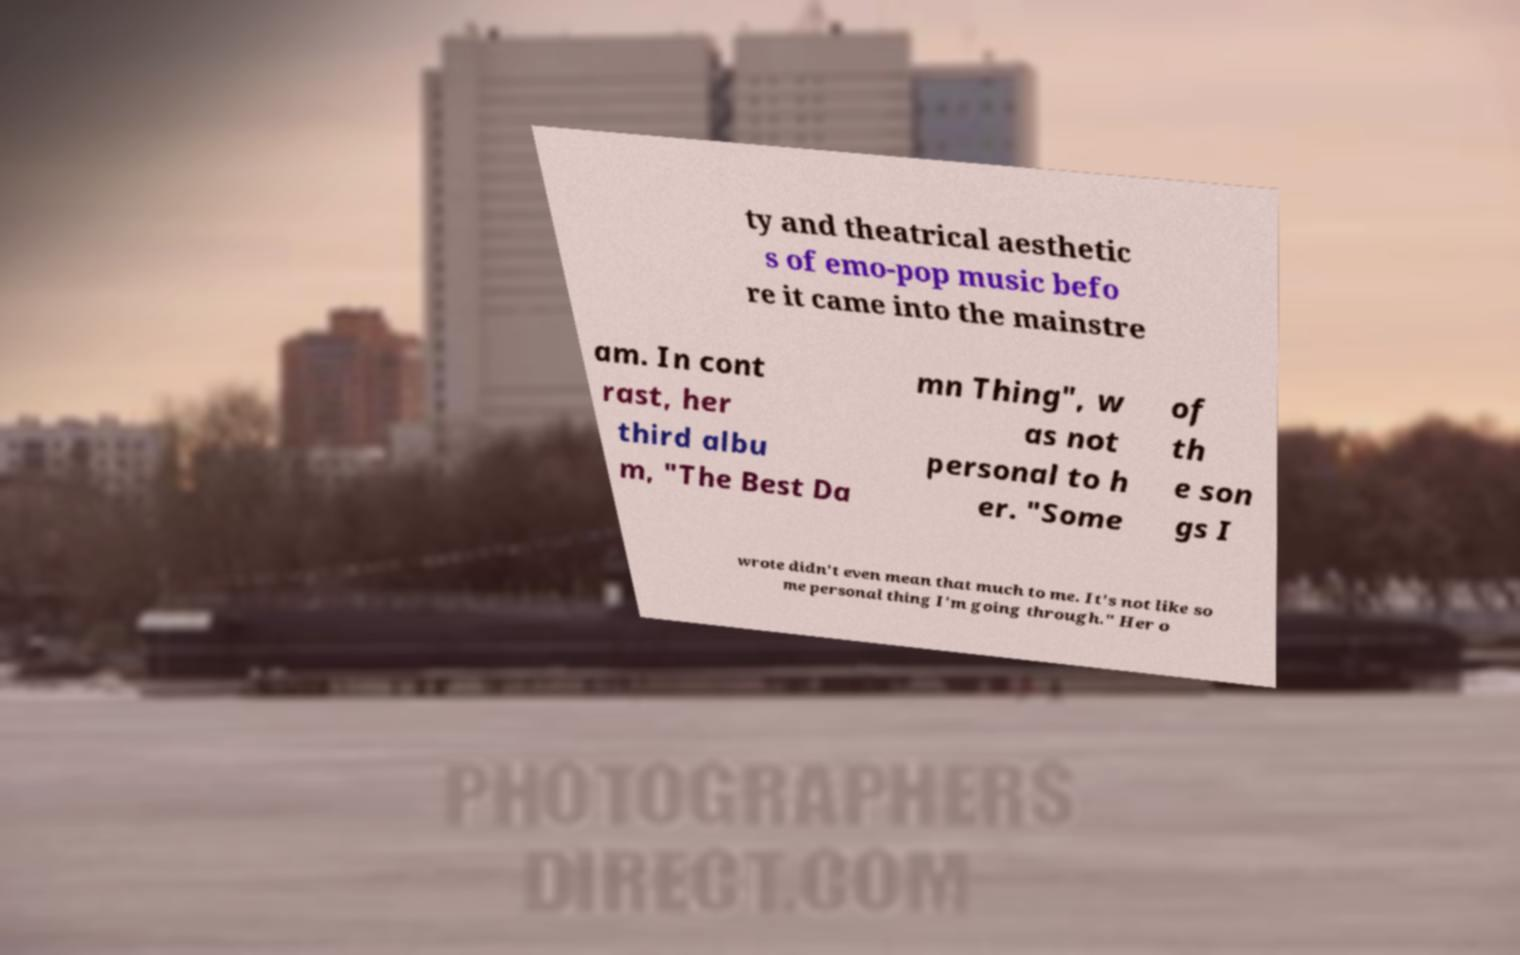There's text embedded in this image that I need extracted. Can you transcribe it verbatim? ty and theatrical aesthetic s of emo-pop music befo re it came into the mainstre am. In cont rast, her third albu m, "The Best Da mn Thing", w as not personal to h er. "Some of th e son gs I wrote didn't even mean that much to me. It's not like so me personal thing I'm going through." Her o 